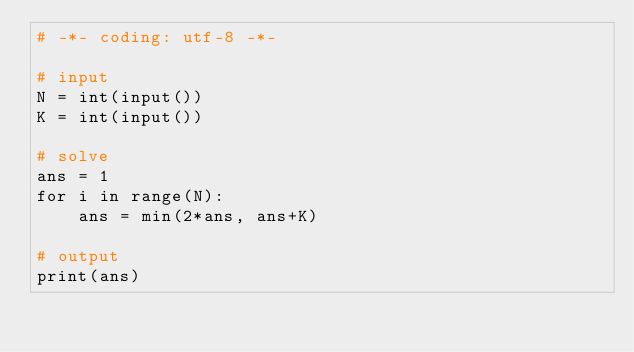<code> <loc_0><loc_0><loc_500><loc_500><_Python_># -*- coding: utf-8 -*-

# input
N = int(input())
K = int(input())

# solve
ans = 1
for i in range(N):
    ans = min(2*ans, ans+K)

# output
print(ans)
</code> 